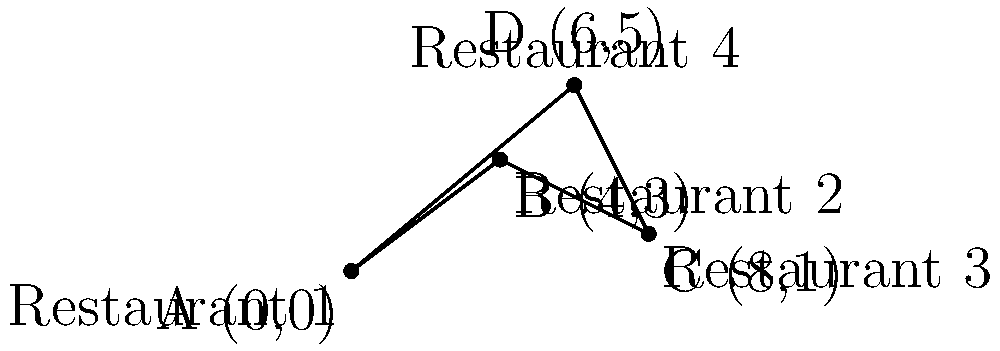As a restaurant owner competing for the best delivery routes, you need to calculate the shortest path to visit all four restaurants in your area for a food brand promotion. Given the coordinates of the restaurants on a city grid: Restaurant 1 at (0,0), Restaurant 2 at (4,3), Restaurant 3 at (8,1), and Restaurant 4 at (6,5), what is the minimum distance required to visit all restaurants and return to the starting point? Assume you can travel in straight lines between restaurants. To solve this problem, we need to calculate the total distance for all possible routes and find the shortest one. This is known as the Traveling Salesman Problem.

Step 1: Calculate distances between all pairs of restaurants using the distance formula:
$d = \sqrt{(x_2-x_1)^2 + (y_2-y_1)^2}$

A to B: $\sqrt{(4-0)^2 + (3-0)^2} = 5$
A to C: $\sqrt{(8-0)^2 + (1-0)^2} = \sqrt{65} \approx 8.06$
A to D: $\sqrt{(6-0)^2 + (5-0)^2} = \sqrt{61} \approx 7.81$
B to C: $\sqrt{(8-4)^2 + (1-3)^2} = \sqrt{20} \approx 4.47$
B to D: $\sqrt{(6-4)^2 + (5-3)^2} = \sqrt{8} \approx 2.83$
C to D: $\sqrt{(6-8)^2 + (5-1)^2} = \sqrt{20} \approx 4.47$

Step 2: Consider all possible routes:
1. A-B-C-D-A
2. A-B-D-C-A
3. A-C-B-D-A
4. A-C-D-B-A
5. A-D-B-C-A
6. A-D-C-B-A

Step 3: Calculate the total distance for each route:
1. A-B-C-D-A = 5 + 4.47 + 4.47 + 7.81 = 21.75
2. A-B-D-C-A = 5 + 2.83 + 4.47 + 8.06 = 20.36
3. A-C-B-D-A = 8.06 + 4.47 + 2.83 + 7.81 = 23.17
4. A-C-D-B-A = 8.06 + 4.47 + 2.83 + 5 = 20.36
5. A-D-B-C-A = 7.81 + 2.83 + 4.47 + 8.06 = 23.17
6. A-D-C-B-A = 7.81 + 4.47 + 4.47 + 5 = 21.75

Step 4: Identify the shortest route:
The shortest routes are A-B-D-C-A and A-C-D-B-A, both with a total distance of 20.36 units.
Answer: 20.36 units 